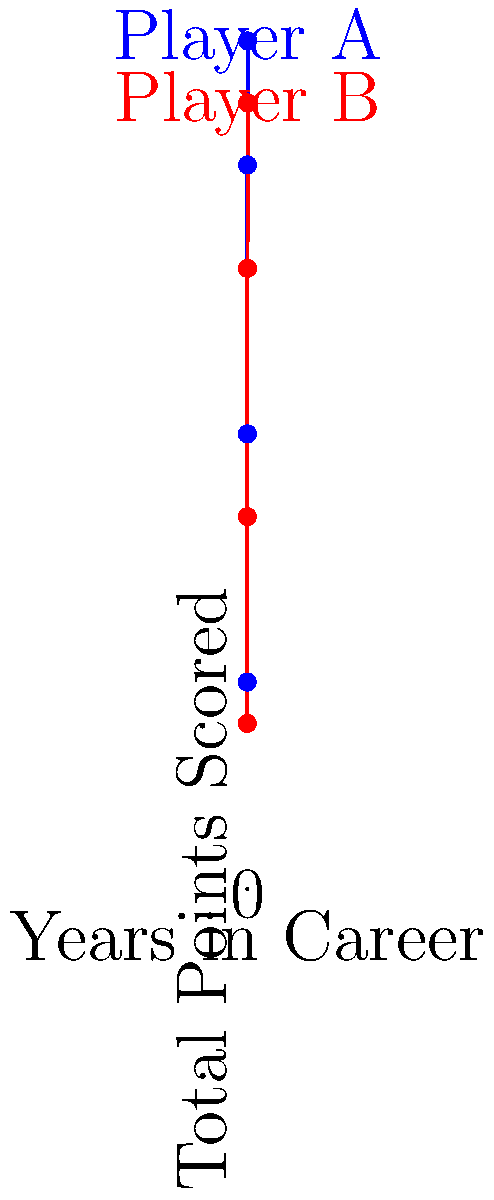The graph shows the total points scored by two legendary basketball players (A and B) over their 20-year careers. Based on the data, which player had a higher average annual point increase during the first 15 years of their career? Calculate the difference in their average annual point increases to support your answer. To solve this problem, we need to calculate the average annual point increase for both players during their first 15 years:

For Player A:
1. Total points at 15 years: 35,000
2. Total points at start: 0
3. Point increase over 15 years: 35,000 - 0 = 35,000
4. Average annual increase: $\frac{35,000}{15} = 2,333.33$ points per year

For Player B:
1. Total points at 15 years: 30,000
2. Total points at start: 0
3. Point increase over 15 years: 30,000 - 0 = 30,000
4. Average annual increase: $\frac{30,000}{15} = 2,000$ points per year

The difference in their average annual point increases:
$2,333.33 - 2,000 = 333.33$ points per year

Player A had a higher average annual point increase during the first 15 years of their career, with a difference of 333.33 points per year more than Player B.
Answer: Player A, by 333.33 points per year 